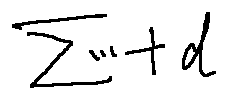<formula> <loc_0><loc_0><loc_500><loc_500>\sum \cdots + d</formula> 